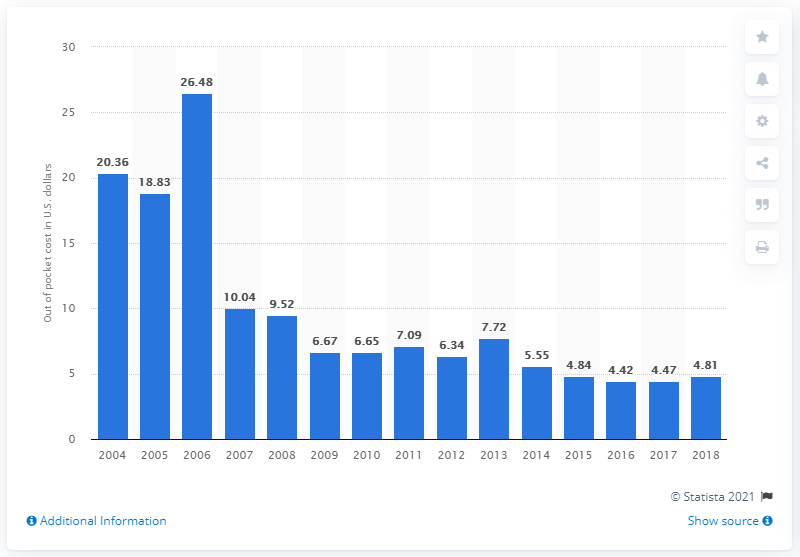List a handful of essential elements in this visual. The cost of metformin hydrochloride in 2018 was 4.81. 